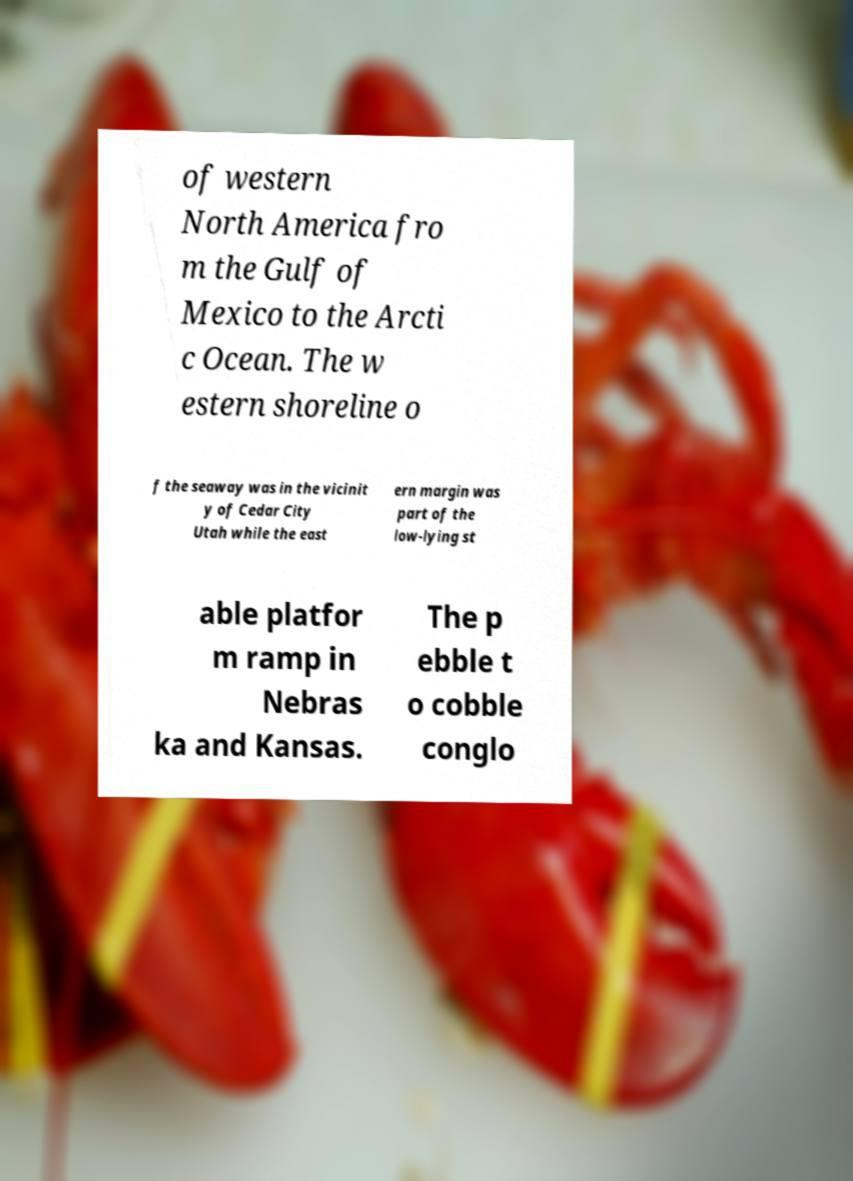What messages or text are displayed in this image? I need them in a readable, typed format. of western North America fro m the Gulf of Mexico to the Arcti c Ocean. The w estern shoreline o f the seaway was in the vicinit y of Cedar City Utah while the east ern margin was part of the low-lying st able platfor m ramp in Nebras ka and Kansas. The p ebble t o cobble conglo 